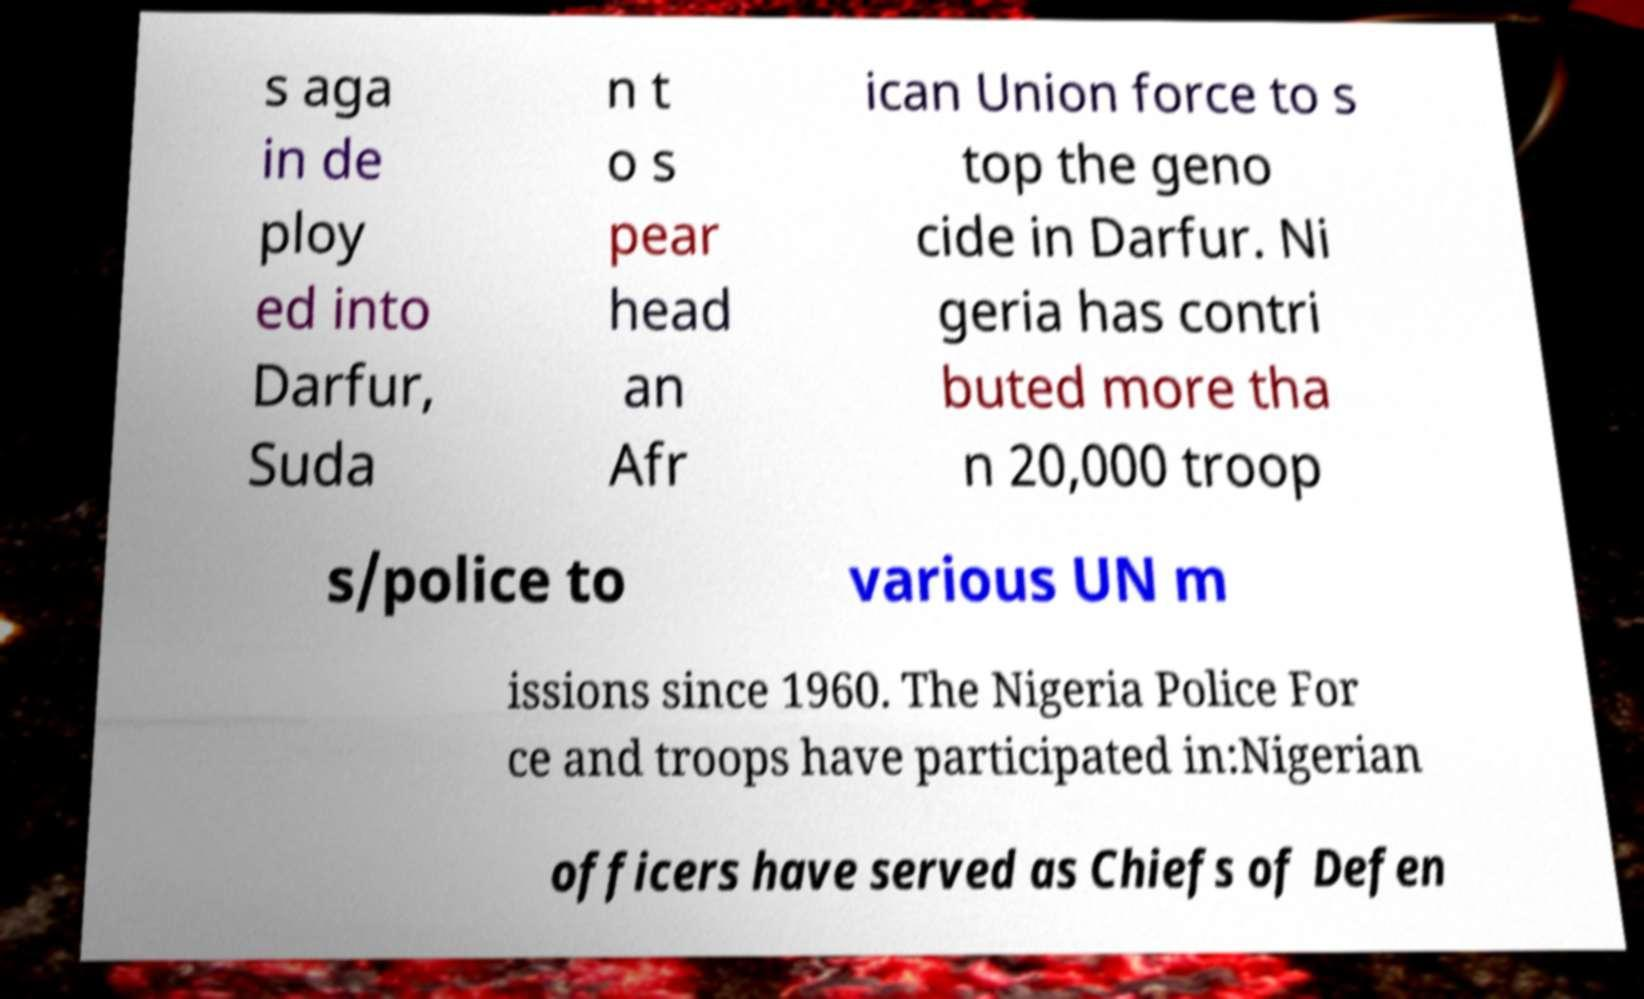Please read and relay the text visible in this image. What does it say? s aga in de ploy ed into Darfur, Suda n t o s pear head an Afr ican Union force to s top the geno cide in Darfur. Ni geria has contri buted more tha n 20,000 troop s/police to various UN m issions since 1960. The Nigeria Police For ce and troops have participated in:Nigerian officers have served as Chiefs of Defen 